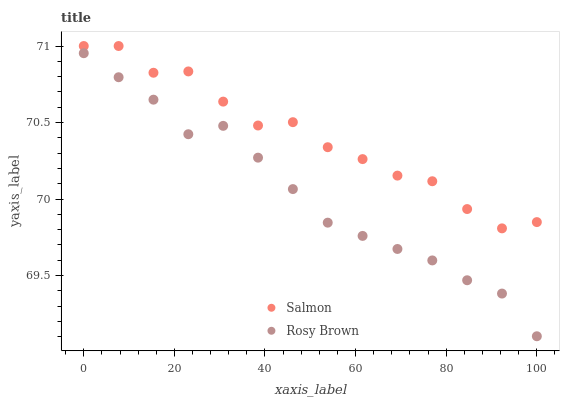Does Rosy Brown have the minimum area under the curve?
Answer yes or no. Yes. Does Salmon have the maximum area under the curve?
Answer yes or no. Yes. Does Salmon have the minimum area under the curve?
Answer yes or no. No. Is Rosy Brown the smoothest?
Answer yes or no. Yes. Is Salmon the roughest?
Answer yes or no. Yes. Is Salmon the smoothest?
Answer yes or no. No. Does Rosy Brown have the lowest value?
Answer yes or no. Yes. Does Salmon have the lowest value?
Answer yes or no. No. Does Salmon have the highest value?
Answer yes or no. Yes. Is Rosy Brown less than Salmon?
Answer yes or no. Yes. Is Salmon greater than Rosy Brown?
Answer yes or no. Yes. Does Rosy Brown intersect Salmon?
Answer yes or no. No. 